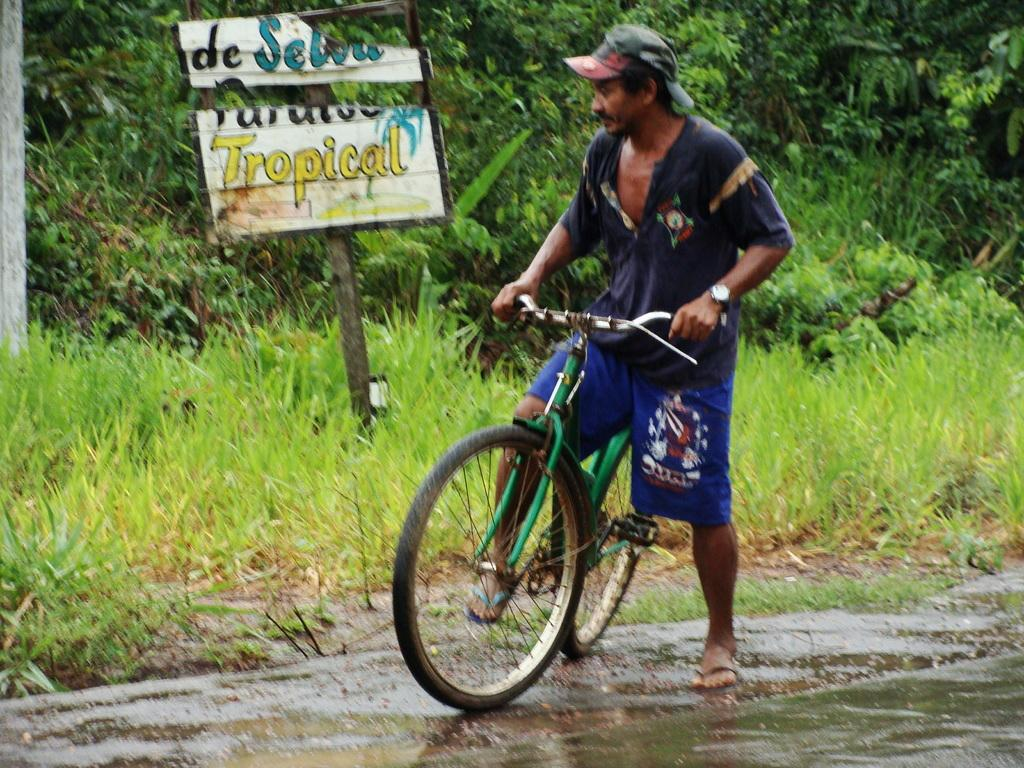What is the man in the image doing? The man is riding a bicycle in the image. What can be seen in the image besides the man and his bicycle? There is a board and grass visible in the image. What is the background of the image? There are trees in the background of the image. What is the man's fear of in the image? There is no indication of fear in the image; the man is simply riding a bicycle. Can you describe the cellar in the image? There is no cellar present in the image. 